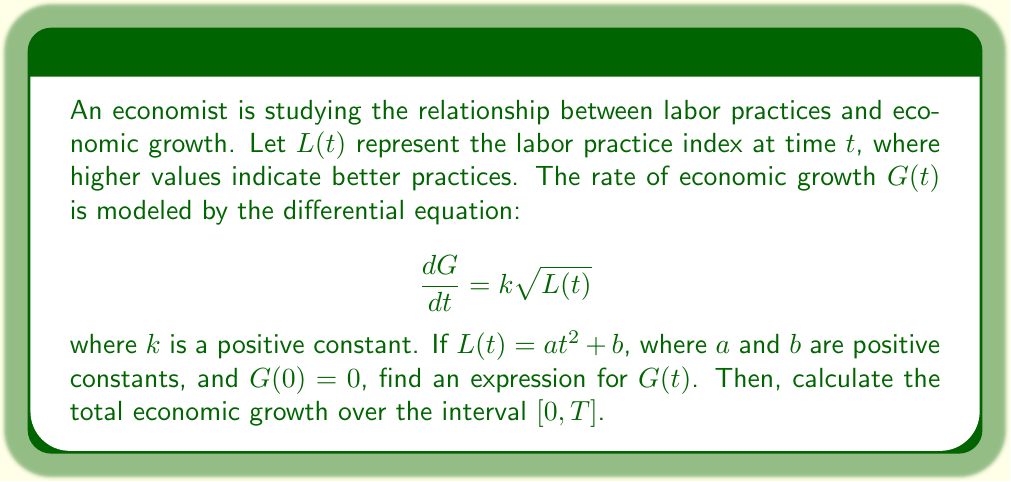Help me with this question. 1) First, we need to solve the differential equation for $G(t)$:

   $$\frac{dG}{dt} = k\sqrt{L(t)} = k\sqrt{at^2 + b}$$

2) To find $G(t)$, we integrate both sides:

   $$G(t) = \int_0^t k\sqrt{at^2 + b} \, dt + C$$

3) This integral can be solved using the substitution $u = at^2 + b$:

   $$G(t) = \frac{k}{2a} \int_b^{at^2+b} \frac{u^{1/2}}{\sqrt{u-b}} \, du + C$$

4) After integration and simplification:

   $$G(t) = \frac{k}{3a} \left[(at^2 + b)\sqrt{at^2 + b} - b\sqrt{b}\right] + C$$

5) Using the initial condition $G(0) = 0$, we can find $C$:

   $$0 = \frac{k}{3a} \left[b\sqrt{b} - b\sqrt{b}\right] + C$$
   $$C = 0$$

6) Therefore, the expression for $G(t)$ is:

   $$G(t) = \frac{k}{3a} \left[(at^2 + b)\sqrt{at^2 + b} - b\sqrt{b}\right]$$

7) To calculate the total economic growth over $[0, T]$, we evaluate $G(T)$:

   $$G(T) = \frac{k}{3a} \left[(aT^2 + b)\sqrt{aT^2 + b} - b\sqrt{b}\right]$$
Answer: $G(t) = \frac{k}{3a} \left[(at^2 + b)\sqrt{at^2 + b} - b\sqrt{b}\right]$; Total growth over $[0, T]$: $\frac{k}{3a} \left[(aT^2 + b)\sqrt{aT^2 + b} - b\sqrt{b}\right]$ 